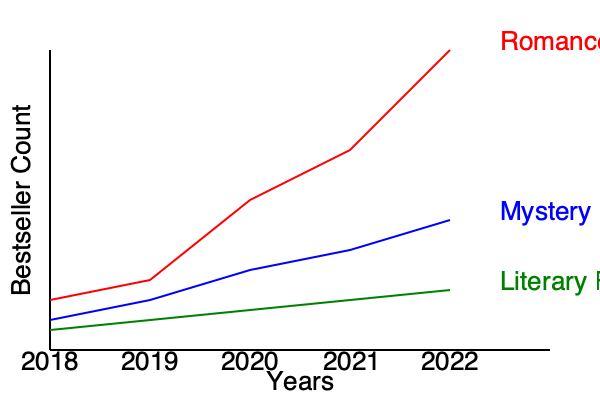Based on the bestseller chart trends shown, which genre appears to have the broadest and most consistent appeal over the five-year period, potentially making it the most reliable for a literary agent to focus on? To determine which genre has the broadest and most consistent appeal, we need to analyze the trends for each genre:

1. Romance (red line):
   - Shows the most dramatic increase in bestsellers over time
   - Starts with the lowest count in 2018 but ends with the highest in 2022
   - Demonstrates high volatility and rapid growth

2. Mystery (blue line):
   - Shows a steady increase in bestsellers over time
   - Maintains a middle position throughout the five-year period
   - Demonstrates consistent growth with moderate volatility

3. Literary Fiction (green line):
   - Shows the least change in bestseller count over time
   - Maintains a relatively stable position throughout the five-year period
   - Demonstrates the most consistent performance with minimal volatility

For a literary agent looking for broad and consistent appeal:

- Romance, while showing impressive growth, may be too volatile and unpredictable.
- Mystery shows steady growth but still has some volatility.
- Literary Fiction, while not showing significant growth, demonstrates the most consistent performance over time.

Given the requirement for broad and consistent appeal, Literary Fiction emerges as the most reliable genre. Its stable trend suggests a dedicated readership and consistent market demand, which could be valuable for a literary agent seeking predictability and long-term stability in their portfolio.
Answer: Literary Fiction 